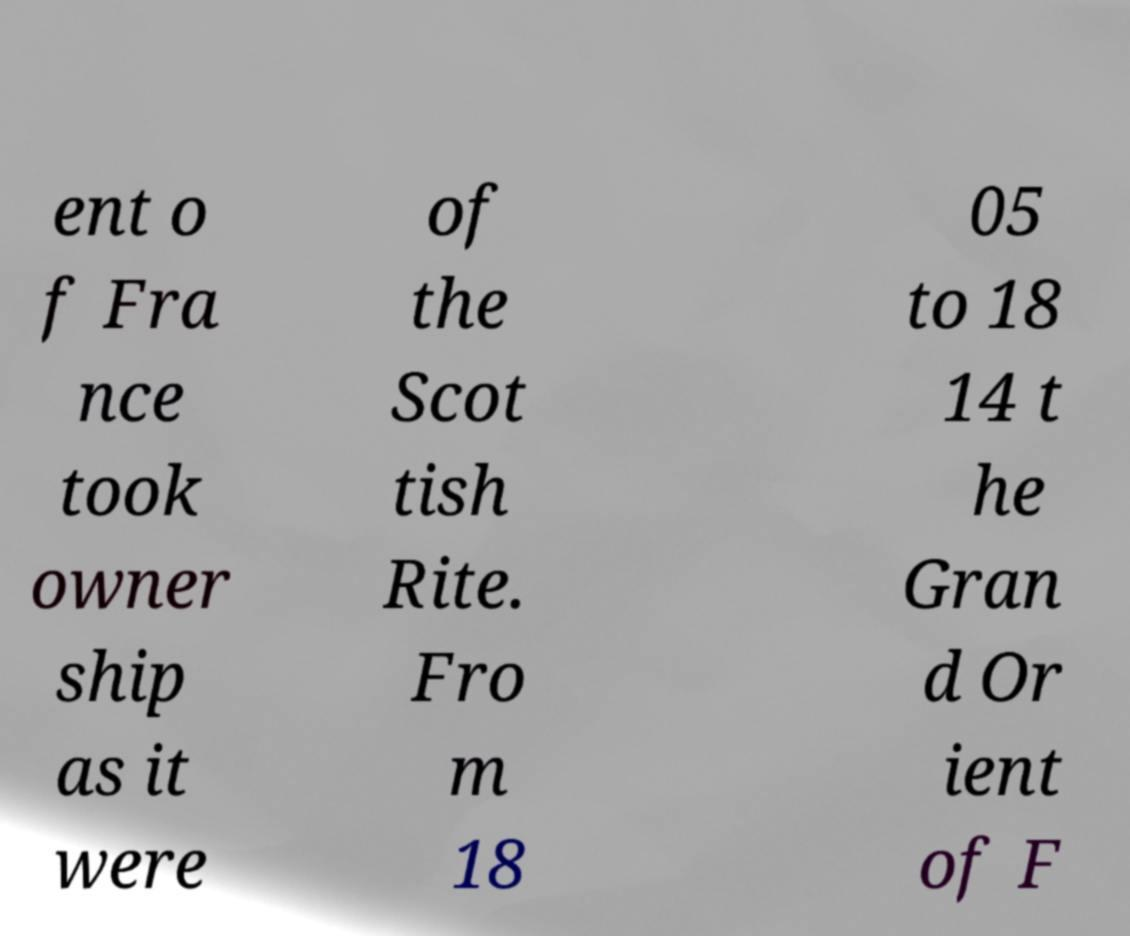Please identify and transcribe the text found in this image. ent o f Fra nce took owner ship as it were of the Scot tish Rite. Fro m 18 05 to 18 14 t he Gran d Or ient of F 